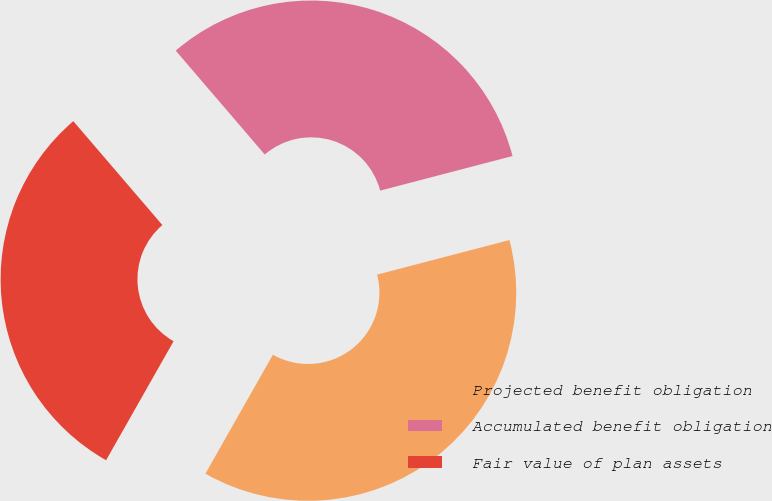<chart> <loc_0><loc_0><loc_500><loc_500><pie_chart><fcel>Projected benefit obligation<fcel>Accumulated benefit obligation<fcel>Fair value of plan assets<nl><fcel>37.28%<fcel>32.21%<fcel>30.51%<nl></chart> 